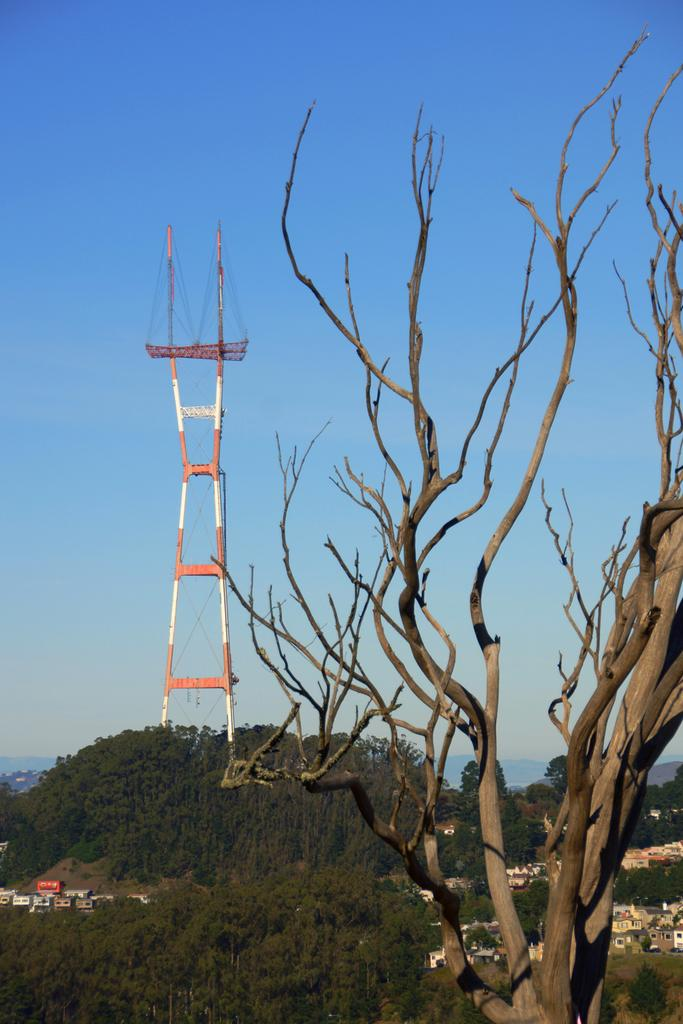What type of tree is in the image? There is a dry tree in the image. What structure is located in the middle of the image? There is a tower in the middle of the image. What type of vegetation is at the bottom of the image? There are trees at the bottom of the image. What is visible in the background of the image? The sky is visible in the background of the image. What type of card is hanging on the frame in the image? There is no card or frame present in the image. What type of soup is being served in the image? There is no soup present in the image. 